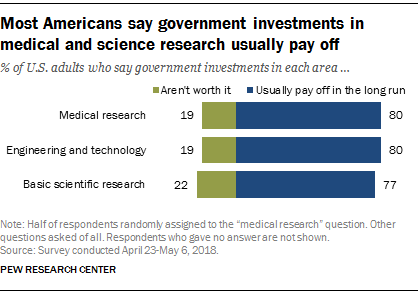Mention a couple of crucial points in this snapshot. The median value of green bars is equal to 19, and the answer is yes. Two bars, namely Medical Research, Engineering, and Technology, are identical in nature and therefore are exactly similar to each other. 